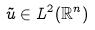Convert formula to latex. <formula><loc_0><loc_0><loc_500><loc_500>\tilde { u } \in L ^ { 2 } ( \mathbb { R } ^ { n } )</formula> 